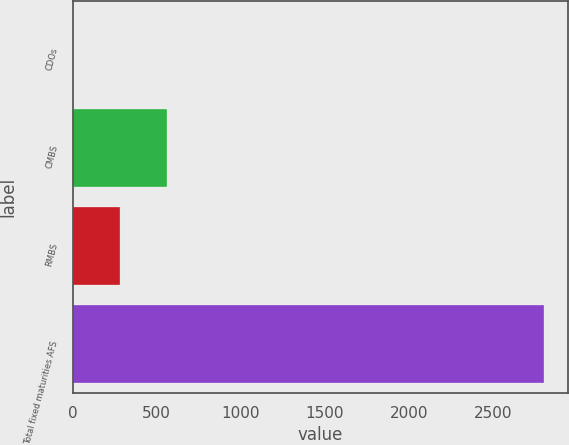Convert chart to OTSL. <chart><loc_0><loc_0><loc_500><loc_500><bar_chart><fcel>CDOs<fcel>CMBS<fcel>RMBS<fcel>Total fixed maturities AFS<nl><fcel>1<fcel>561.6<fcel>281.3<fcel>2804<nl></chart> 